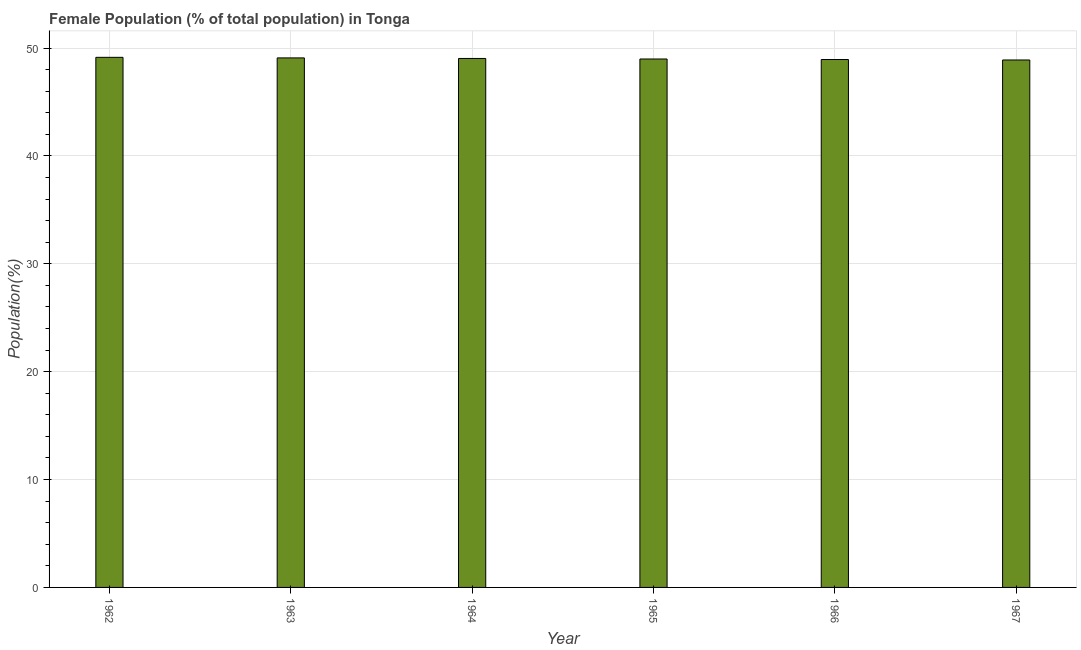Does the graph contain any zero values?
Your answer should be very brief. No. Does the graph contain grids?
Make the answer very short. Yes. What is the title of the graph?
Your answer should be compact. Female Population (% of total population) in Tonga. What is the label or title of the X-axis?
Make the answer very short. Year. What is the label or title of the Y-axis?
Ensure brevity in your answer.  Population(%). What is the female population in 1963?
Your answer should be compact. 49.09. Across all years, what is the maximum female population?
Provide a succinct answer. 49.14. Across all years, what is the minimum female population?
Ensure brevity in your answer.  48.9. In which year was the female population minimum?
Offer a very short reply. 1967. What is the sum of the female population?
Keep it short and to the point. 294.1. What is the difference between the female population in 1962 and 1966?
Provide a short and direct response. 0.2. What is the average female population per year?
Keep it short and to the point. 49.02. What is the median female population?
Provide a succinct answer. 49.01. Do a majority of the years between 1964 and 1965 (inclusive) have female population greater than 28 %?
Ensure brevity in your answer.  Yes. What is the ratio of the female population in 1966 to that in 1967?
Give a very brief answer. 1. Is the female population in 1963 less than that in 1966?
Offer a very short reply. No. What is the difference between the highest and the second highest female population?
Ensure brevity in your answer.  0.05. How many bars are there?
Give a very brief answer. 6. How many years are there in the graph?
Provide a short and direct response. 6. Are the values on the major ticks of Y-axis written in scientific E-notation?
Provide a short and direct response. No. What is the Population(%) in 1962?
Your answer should be very brief. 49.14. What is the Population(%) in 1963?
Ensure brevity in your answer.  49.09. What is the Population(%) of 1964?
Give a very brief answer. 49.04. What is the Population(%) in 1965?
Offer a very short reply. 48.99. What is the Population(%) of 1966?
Make the answer very short. 48.94. What is the Population(%) in 1967?
Provide a short and direct response. 48.9. What is the difference between the Population(%) in 1962 and 1963?
Ensure brevity in your answer.  0.05. What is the difference between the Population(%) in 1962 and 1964?
Keep it short and to the point. 0.1. What is the difference between the Population(%) in 1962 and 1965?
Your answer should be very brief. 0.15. What is the difference between the Population(%) in 1962 and 1966?
Ensure brevity in your answer.  0.2. What is the difference between the Population(%) in 1962 and 1967?
Offer a very short reply. 0.25. What is the difference between the Population(%) in 1963 and 1964?
Your answer should be compact. 0.05. What is the difference between the Population(%) in 1963 and 1965?
Give a very brief answer. 0.1. What is the difference between the Population(%) in 1963 and 1966?
Offer a very short reply. 0.15. What is the difference between the Population(%) in 1963 and 1967?
Make the answer very short. 0.19. What is the difference between the Population(%) in 1964 and 1965?
Your answer should be compact. 0.05. What is the difference between the Population(%) in 1964 and 1966?
Keep it short and to the point. 0.1. What is the difference between the Population(%) in 1964 and 1967?
Offer a very short reply. 0.14. What is the difference between the Population(%) in 1965 and 1966?
Your response must be concise. 0.05. What is the difference between the Population(%) in 1965 and 1967?
Provide a succinct answer. 0.09. What is the difference between the Population(%) in 1966 and 1967?
Your answer should be compact. 0.04. What is the ratio of the Population(%) in 1962 to that in 1963?
Offer a very short reply. 1. What is the ratio of the Population(%) in 1962 to that in 1964?
Provide a succinct answer. 1. What is the ratio of the Population(%) in 1962 to that in 1967?
Offer a terse response. 1. What is the ratio of the Population(%) in 1963 to that in 1965?
Ensure brevity in your answer.  1. What is the ratio of the Population(%) in 1964 to that in 1966?
Offer a very short reply. 1. 